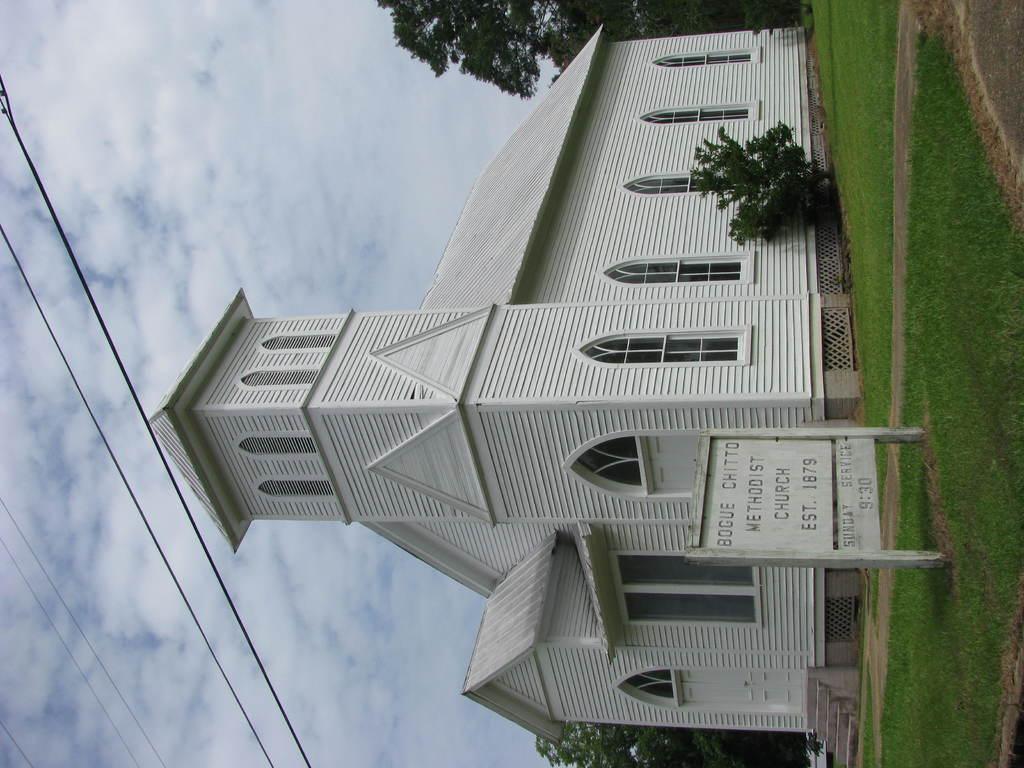When was the church established?
Provide a short and direct response. 1879. 